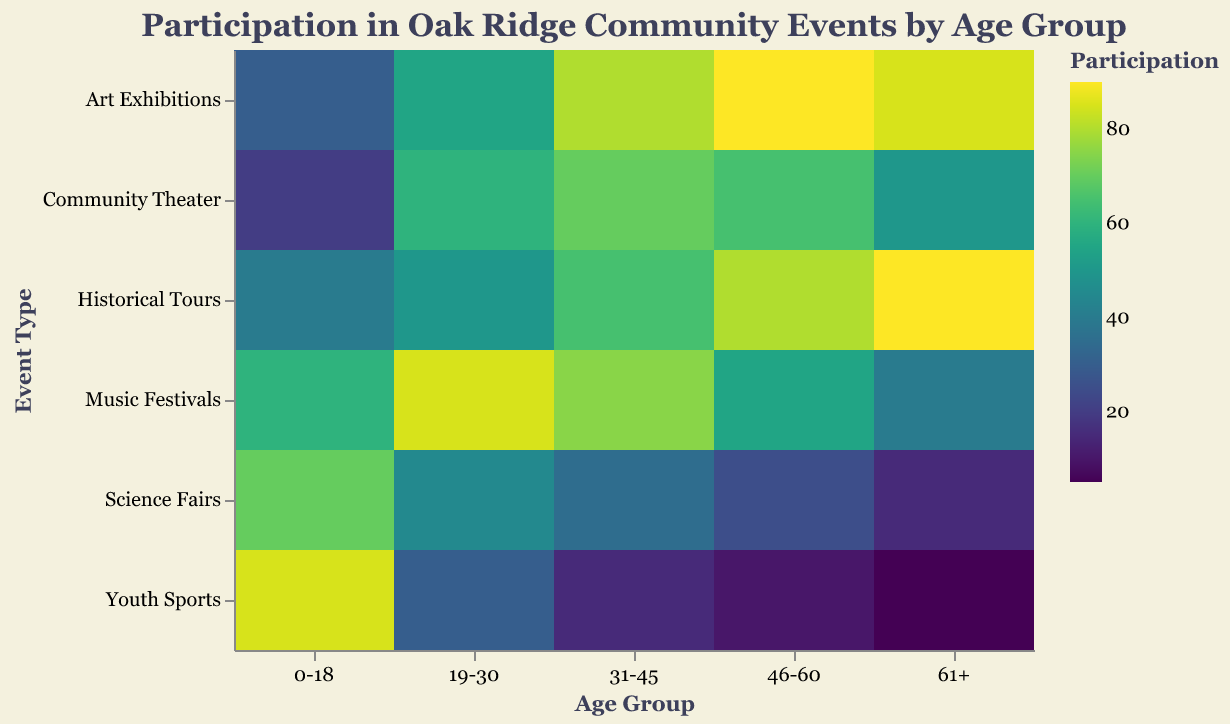What is the highest participation rate in Youth Sports for any age group? The highest value within the "Youth Sports" column is 85, which corresponds to the "0-18" age group.
Answer: 85 Which age group has the least participation in Science Fairs? The "61+" age group has the lowest value of 15 in the "Science Fairs" column.
Answer: 61+ How does participation in Music Festivals compare between the "19-30" and the "61+" age groups? The participation for "19-30" is 85, whereas for "61+" it is 40. Comparing the two, the "19-30" age group has a higher participation rate.
Answer: The "19-30" age group has higher participation What age group participates most in Art Exhibitions? The "46-60" age group shows the highest number with 90 in the "Art Exhibitions" column.
Answer: 46-60 Is the participation in Community Theater higher for the "31-45" or the "46-60" age groups? For "31-45," the value is 70, and for "46-60," it is 65. Comparing these values, the participation is higher for the "31-45" age group.
Answer: 31-45 Compare the participation in Youth Sports and Community Theater for the "19-30" age group. For "Youth Sports," the participation is 30, and for "Community Theater," it's 60. "Community Theater" has a higher participation rate for this age group.
Answer: Community Theater 